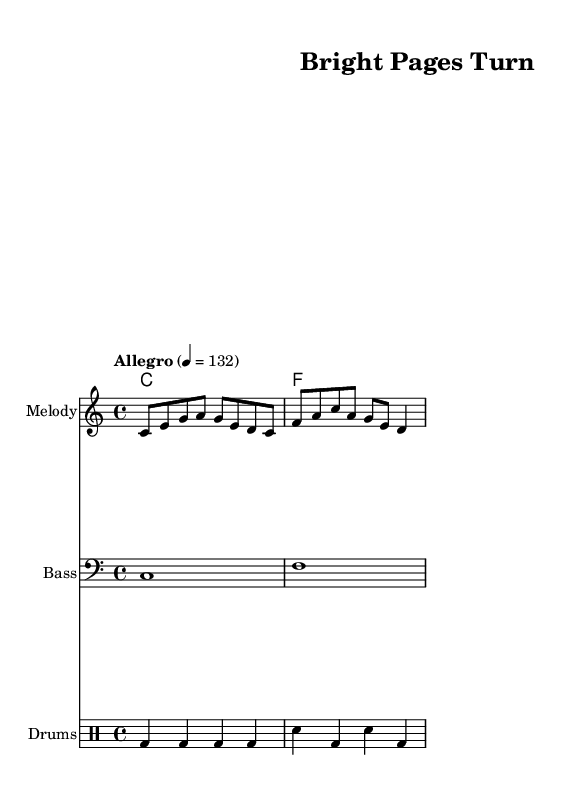What is the key signature of this music? The key signature is C major, which has no sharps or flats.
Answer: C major What is the time signature of this piece? The time signature is indicated as 4/4, meaning there are four beats in each measure.
Answer: 4/4 What is the tempo marking for this music? The tempo marking is "Allegro," indicating a lively and fast tempo, specifically set at 132 beats per minute.
Answer: Allegro How many measures are in the melody section? The melody section consists of two measures: the first measure contains eight eighth notes, and the second measure contains four notes.
Answer: 2 What are the root chords played in this piece? The root chords presented in the harmonies consist of C major and F major.
Answer: C, F What is the overall style of this song? The overall style is upbeat and indie pop, which is typical for songs meant for young adult contemporary settings.
Answer: Upbeat indie pop How many different instruments are represented in the score? There are four different instrument parts represented: melody, bass, drums, and harmony chord names.
Answer: 4 